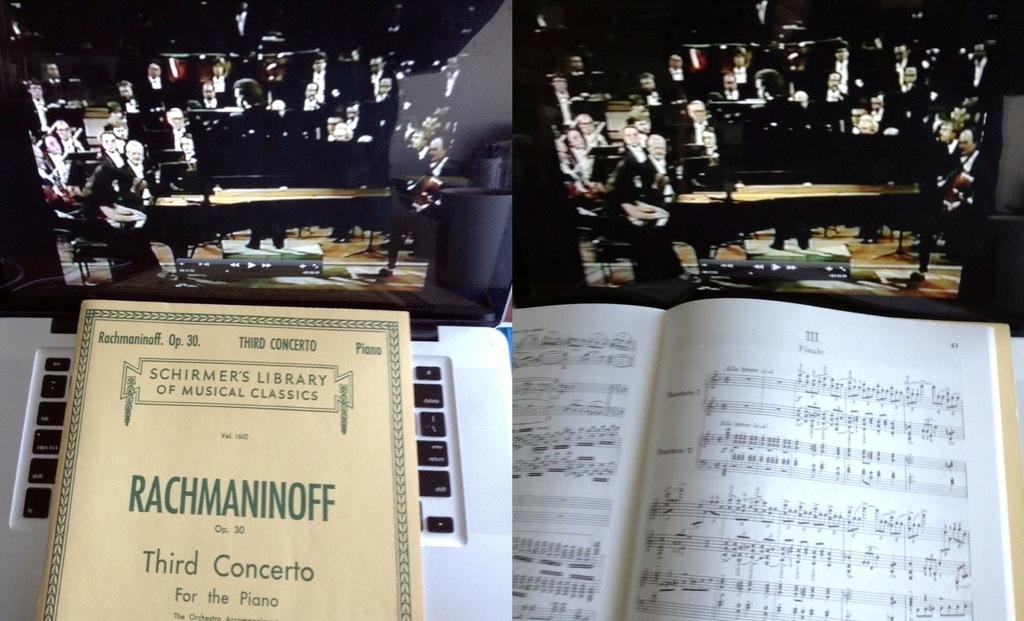What type of artwork is the image? The image is a collage. What objects can be seen in the collage? There are books in the image. Who or what else is present in the collage? There are people in the image. What type of boat is featured in the image? There is no boat present in the image; it is a collage featuring books and people. What nation is represented by the people in the image? The image does not specify a particular nation; it only shows people without any identifying features. 